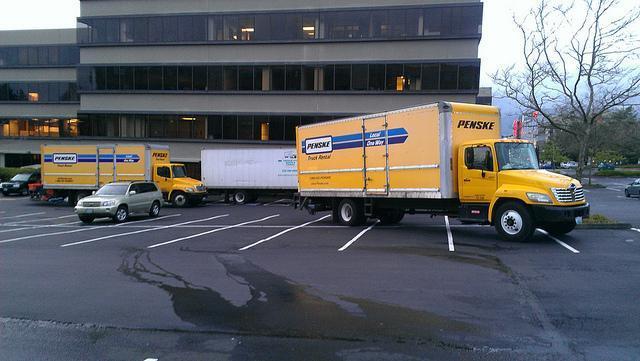How many trucks are in the photo?
Give a very brief answer. 3. How many people are holding skateboards?
Give a very brief answer. 0. 